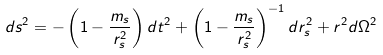Convert formula to latex. <formula><loc_0><loc_0><loc_500><loc_500>d s ^ { 2 } = - \left ( 1 - \frac { m _ { s } } { r _ { s } ^ { 2 } } \right ) d t ^ { 2 } + \left ( 1 - \frac { m _ { s } } { r _ { s } ^ { 2 } } \right ) ^ { - 1 } d r _ { s } ^ { 2 } + r ^ { 2 } d \Omega ^ { 2 }</formula> 